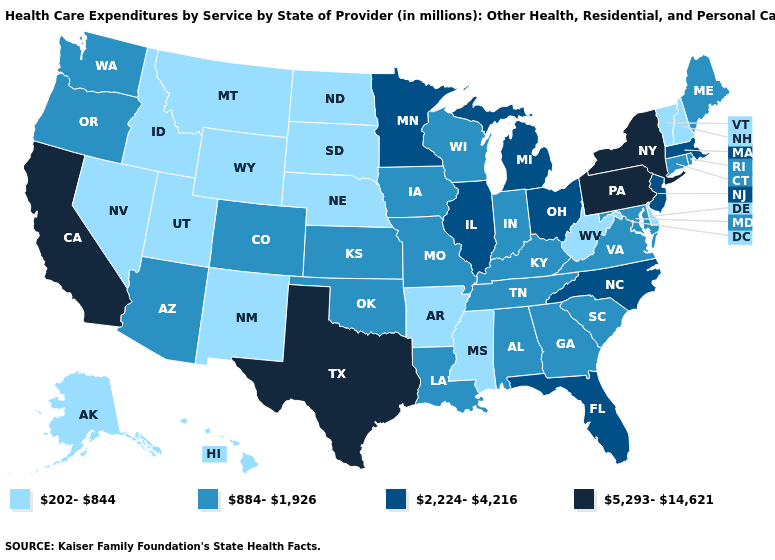Does the first symbol in the legend represent the smallest category?
Short answer required. Yes. Does Maine have the lowest value in the USA?
Short answer required. No. Does Louisiana have the highest value in the South?
Be succinct. No. Is the legend a continuous bar?
Concise answer only. No. What is the lowest value in the MidWest?
Be succinct. 202-844. Does West Virginia have a lower value than Pennsylvania?
Short answer required. Yes. What is the value of Connecticut?
Be succinct. 884-1,926. Does Florida have the same value as Ohio?
Short answer required. Yes. Name the states that have a value in the range 884-1,926?
Write a very short answer. Alabama, Arizona, Colorado, Connecticut, Georgia, Indiana, Iowa, Kansas, Kentucky, Louisiana, Maine, Maryland, Missouri, Oklahoma, Oregon, Rhode Island, South Carolina, Tennessee, Virginia, Washington, Wisconsin. What is the value of Montana?
Write a very short answer. 202-844. Which states have the lowest value in the USA?
Write a very short answer. Alaska, Arkansas, Delaware, Hawaii, Idaho, Mississippi, Montana, Nebraska, Nevada, New Hampshire, New Mexico, North Dakota, South Dakota, Utah, Vermont, West Virginia, Wyoming. Does the first symbol in the legend represent the smallest category?
Answer briefly. Yes. Does South Dakota have a lower value than Kentucky?
Quick response, please. Yes. Does Utah have a higher value than Idaho?
Answer briefly. No. What is the value of Idaho?
Answer briefly. 202-844. 